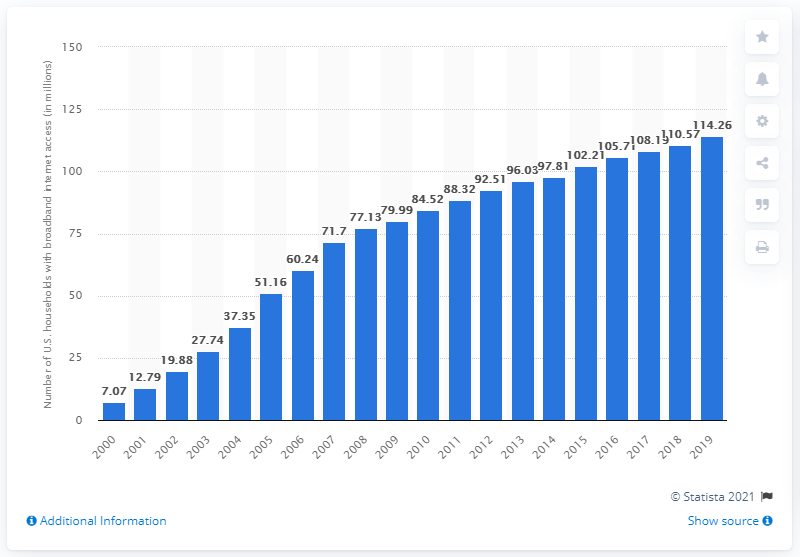Give some essential details in this illustration. In 2019, approximately 114.26 million households in the United States had access to broadband internet. 